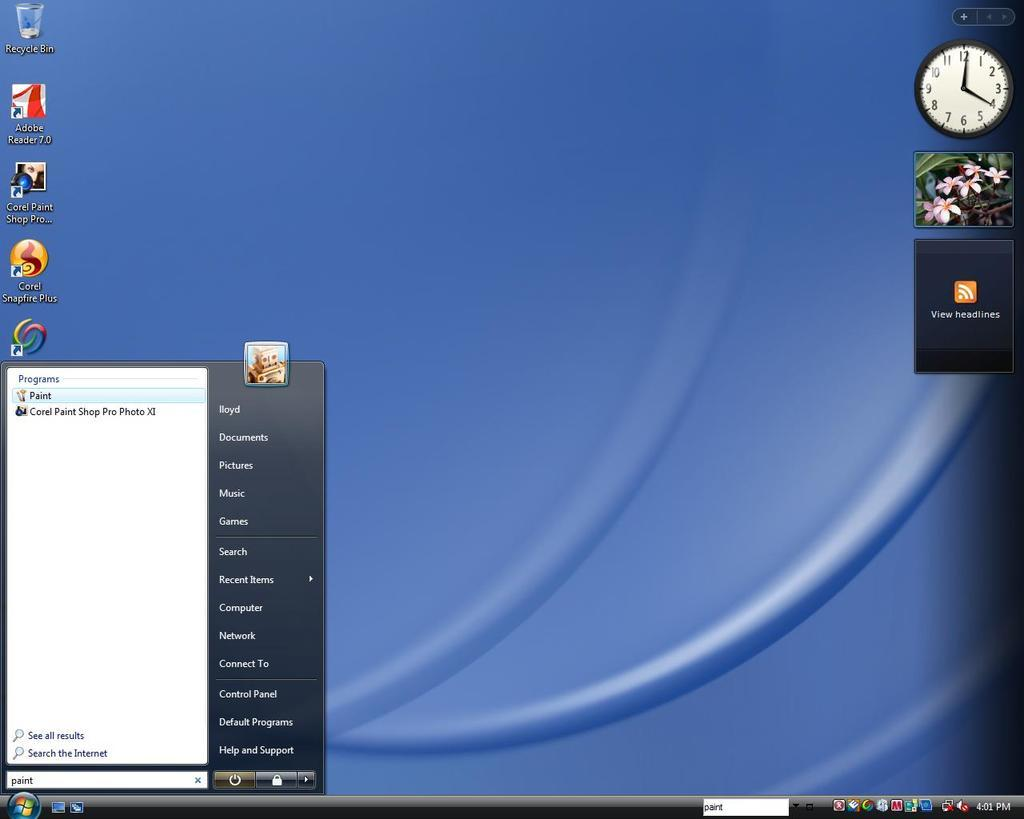<image>
Create a compact narrative representing the image presented. Computer screen which shows someone hovering on the PAINT app. 